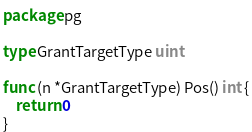Convert code to text. <code><loc_0><loc_0><loc_500><loc_500><_Go_>package pg

type GrantTargetType uint

func (n *GrantTargetType) Pos() int {
	return 0
}
</code> 